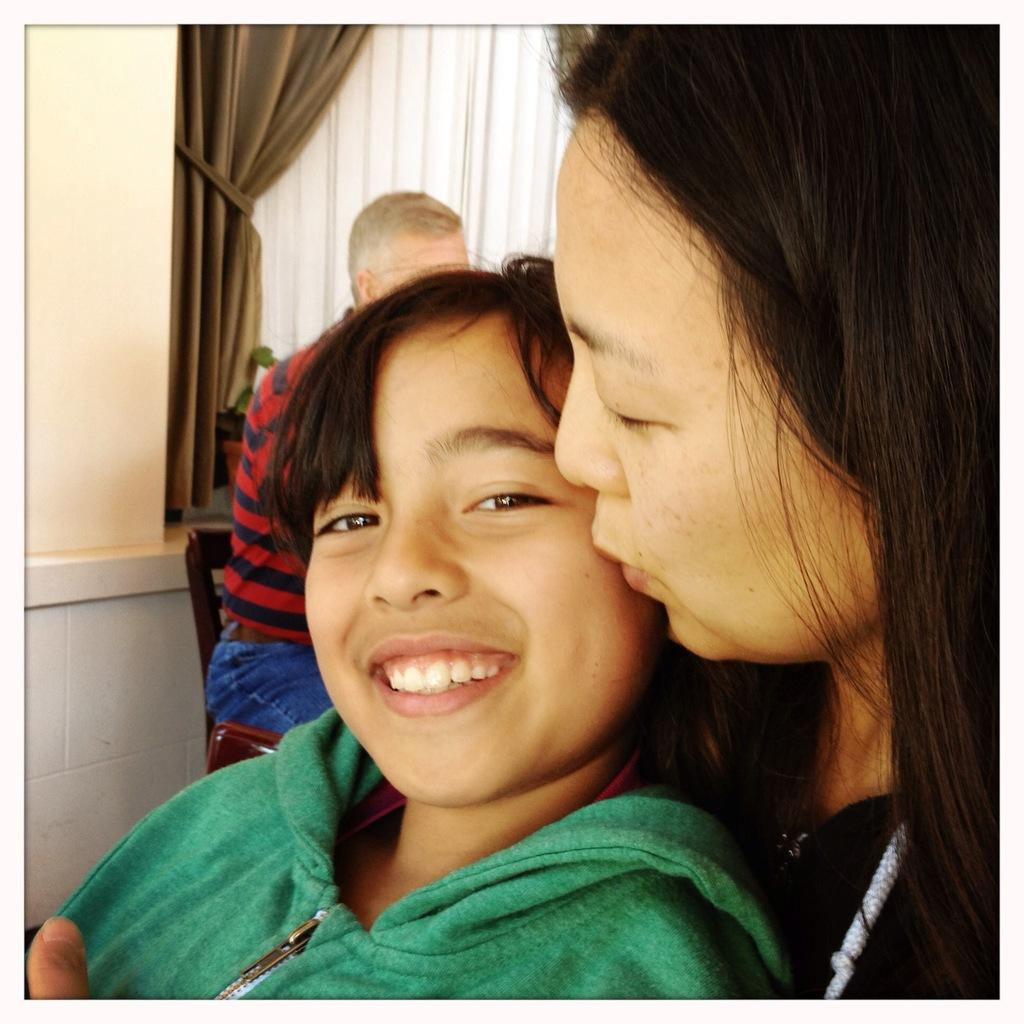Who is present in the image? There is a woman and a child in the image. What is the woman doing in the image? The woman is sitting on a chair in the image. What can be seen on the wall in the image? There are curtains on the wall in the image. What type of meat is being cooked on the stove in the image? There is no stove or meat present in the image. What sound does the bell make when it is rung in the image? There is no bell present in the image. 